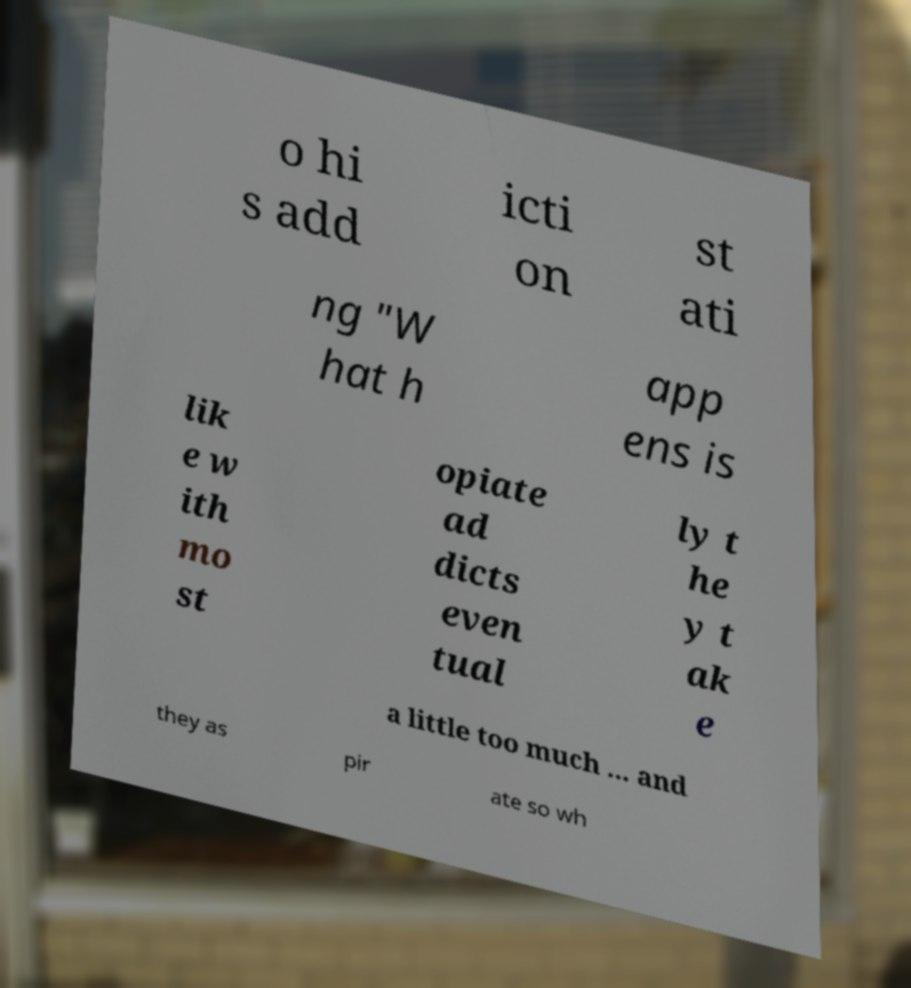Please read and relay the text visible in this image. What does it say? o hi s add icti on st ati ng "W hat h app ens is lik e w ith mo st opiate ad dicts even tual ly t he y t ak e a little too much ... and they as pir ate so wh 